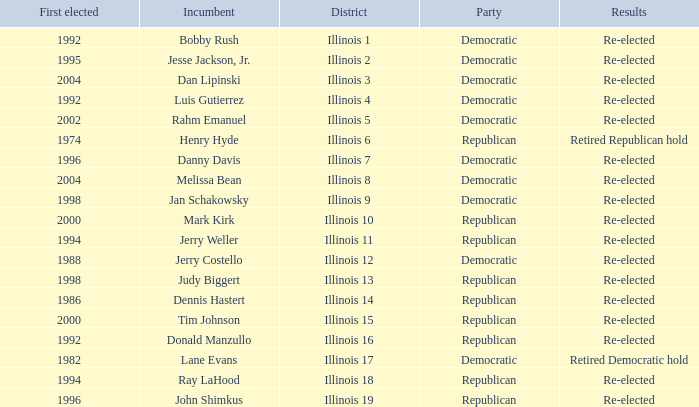What is re-elected Incumbent Jerry Costello's First elected date? 1988.0. 